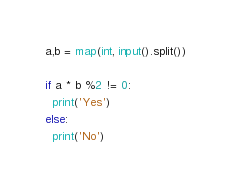<code> <loc_0><loc_0><loc_500><loc_500><_Python_>a,b = map(int, input().split())

if a * b %2 != 0:
  print('Yes')
else:
  print('No')</code> 